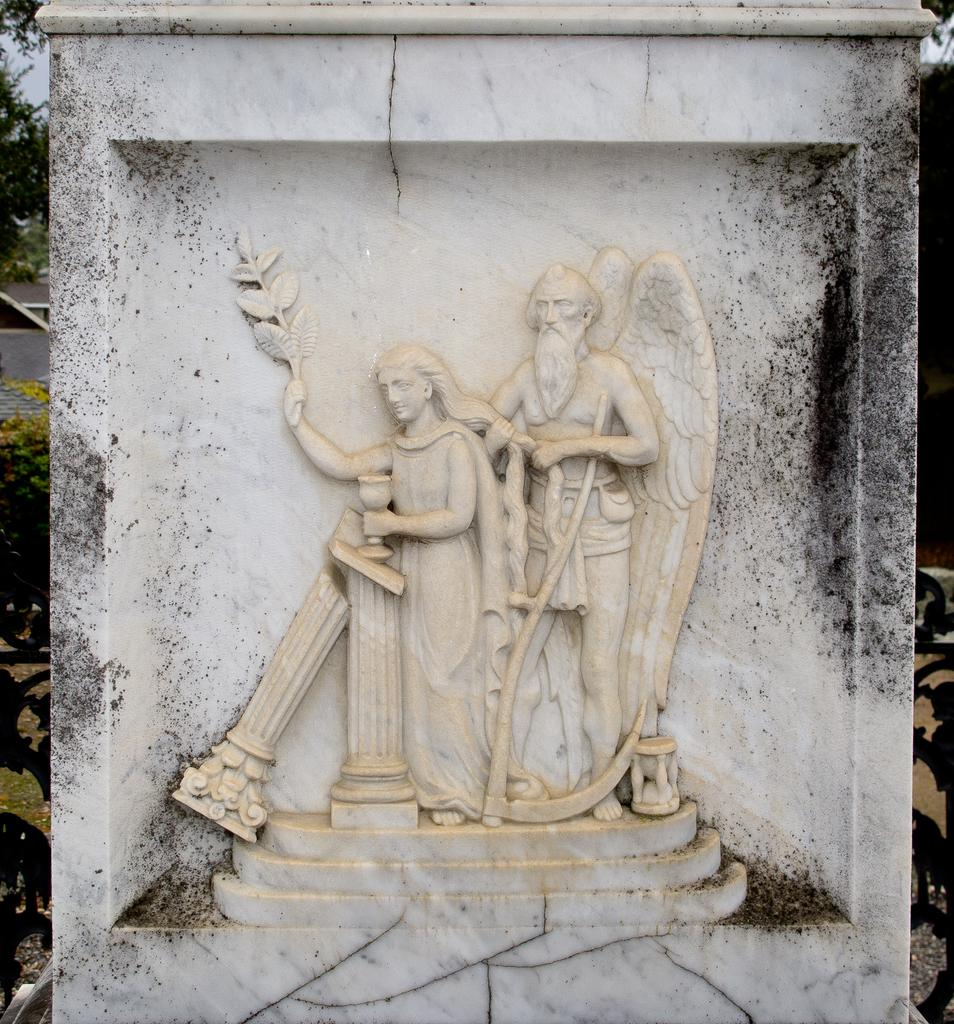What type of sculptures can be seen in the image? There is a sculpture of a man and a sculpture of a woman in the image. Are there any other sculptures or objects present in the image? Yes, there are other sculptures or objects in the image. What can be seen in the background of the image? There is a sky and a tree visible in the background of the image. How many snails are crawling on the sculpture of the woman in the image? There are no snails present in the image, as it features sculptures of a man and a woman with no snails visible. 